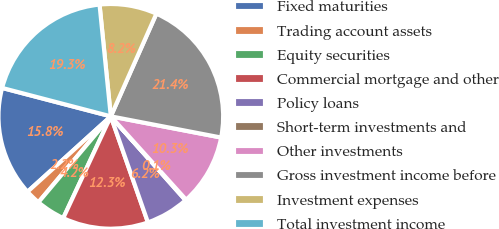Convert chart to OTSL. <chart><loc_0><loc_0><loc_500><loc_500><pie_chart><fcel>Fixed maturities<fcel>Trading account assets<fcel>Equity securities<fcel>Commercial mortgage and other<fcel>Policy loans<fcel>Short-term investments and<fcel>Other investments<fcel>Gross investment income before<fcel>Investment expenses<fcel>Total investment income<nl><fcel>15.78%<fcel>2.15%<fcel>4.18%<fcel>12.32%<fcel>6.22%<fcel>0.11%<fcel>10.29%<fcel>21.37%<fcel>8.25%<fcel>19.33%<nl></chart> 